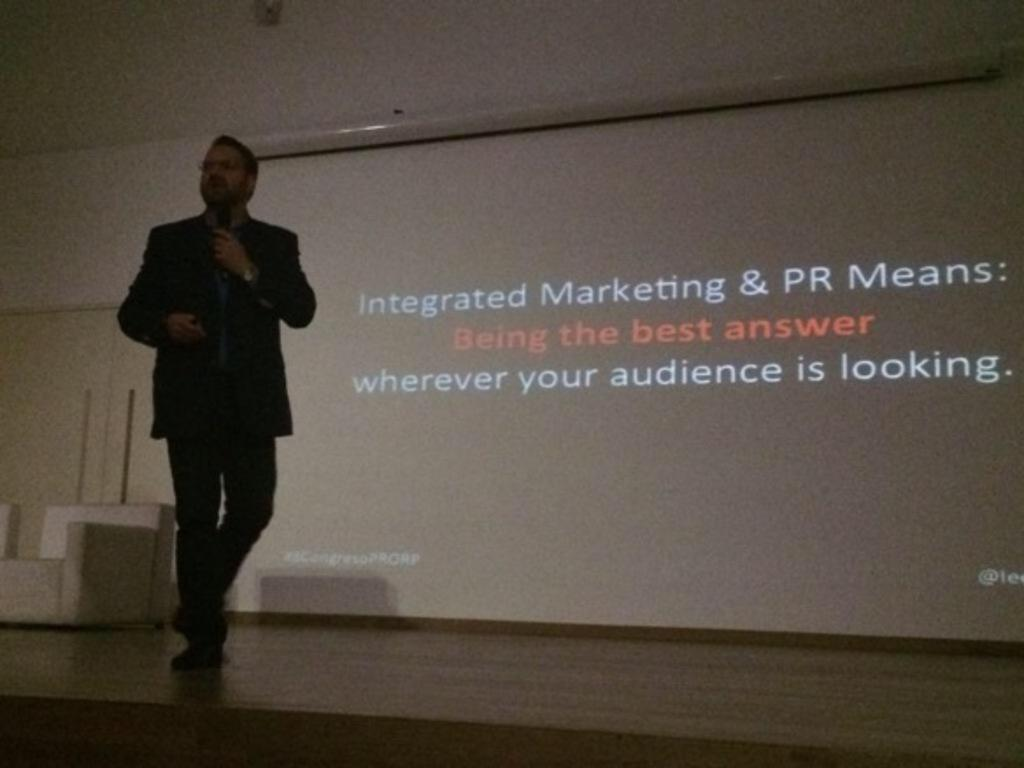Who is present in the image? There is a person in the image. What is the person doing in the image? The person is walking on a stage and holding a microphone. What objects can be seen in the image besides the person? There is a chair, a projector screen, and a wall in the image. What type of clam can be seen on the wall in the image? There is no clam present on the wall in the image. How does the sea affect the person's performance on the stage? There is no reference to a sea or any water body in the image, so it cannot be determined how it might affect the person's performance. 